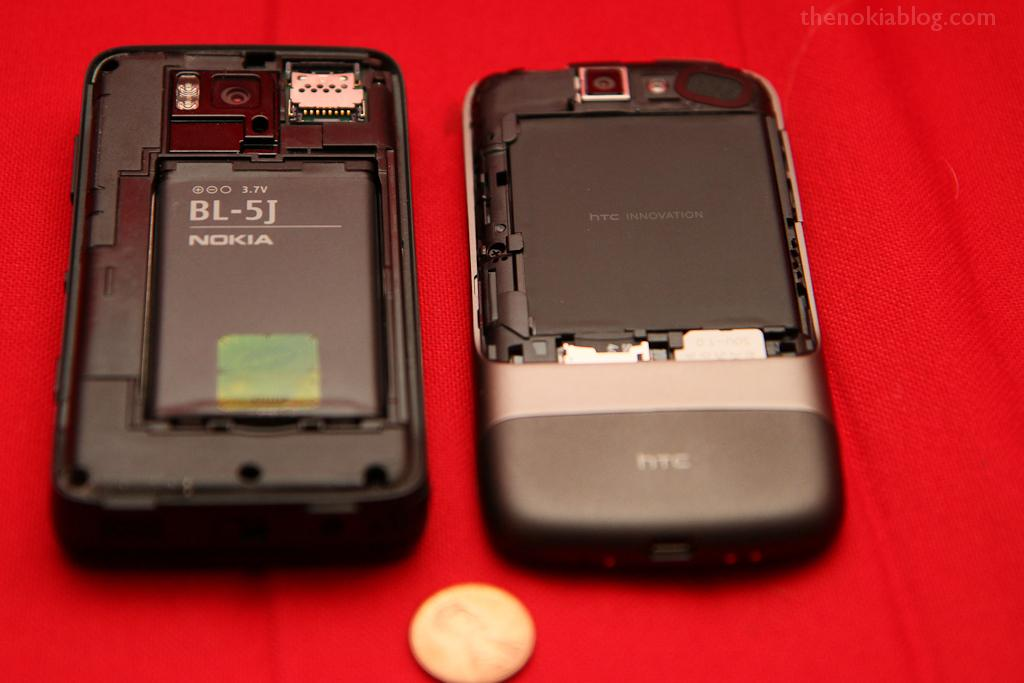Provide a one-sentence caption for the provided image. The back of a cell phone has been removed to display a Nokia battery. 